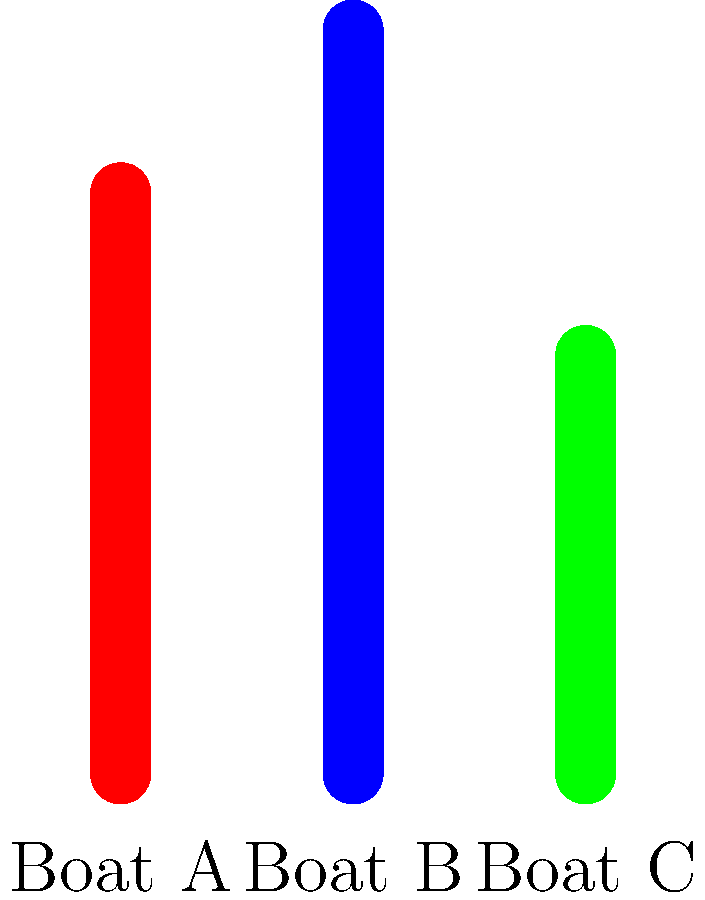As a travel agent organizing fishing trips, you need to compare the fuel efficiency of three boats for a remote expedition. The graph shows the fuel efficiency in miles per gallon (MPG) for Boats A, B, and C. If the trip requires traveling 480 miles round trip, how many fewer gallons of fuel would Boat B use compared to Boat A for the entire journey? To solve this problem, we'll follow these steps:

1. Identify the fuel efficiency (MPG) for Boats A and B:
   Boat A: $2.5$ MPG
   Boat B: $3.2$ MPG

2. Calculate the amount of fuel needed for each boat to travel 480 miles:
   
   For Boat A: 
   $\text{Fuel needed}_A = \frac{\text{Distance}}{\text{MPG}_A} = \frac{480 \text{ miles}}{2.5 \text{ MPG}} = 192 \text{ gallons}$
   
   For Boat B:
   $\text{Fuel needed}_B = \frac{\text{Distance}}{\text{MPG}_B} = \frac{480 \text{ miles}}{3.2 \text{ MPG}} = 150 \text{ gallons}$

3. Calculate the difference in fuel consumption:
   $\text{Fuel saved} = \text{Fuel needed}_A - \text{Fuel needed}_B = 192 \text{ gallons} - 150 \text{ gallons} = 42 \text{ gallons}$

Therefore, Boat B would use 42 fewer gallons of fuel compared to Boat A for the entire 480-mile round trip.
Answer: 42 gallons 